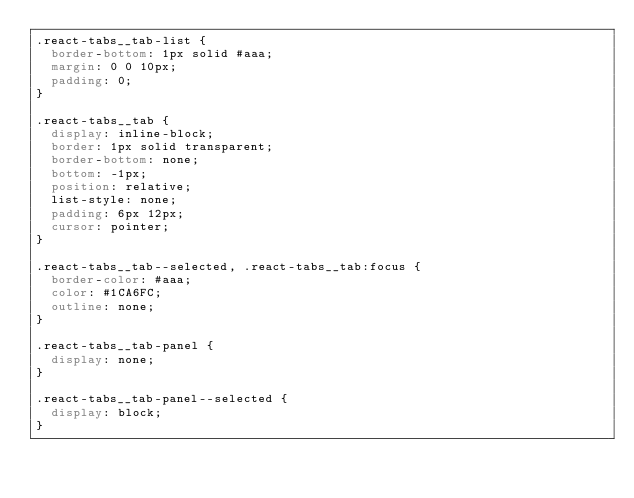<code> <loc_0><loc_0><loc_500><loc_500><_CSS_>.react-tabs__tab-list {
  border-bottom: 1px solid #aaa;
  margin: 0 0 10px;
  padding: 0;
}

.react-tabs__tab {
  display: inline-block;
  border: 1px solid transparent;
  border-bottom: none;
  bottom: -1px;
  position: relative;
  list-style: none;
  padding: 6px 12px;
  cursor: pointer;
}

.react-tabs__tab--selected, .react-tabs__tab:focus {
  border-color: #aaa;
  color: #1CA6FC;
  outline: none;
}

.react-tabs__tab-panel {
  display: none;
}

.react-tabs__tab-panel--selected {
  display: block;
}</code> 